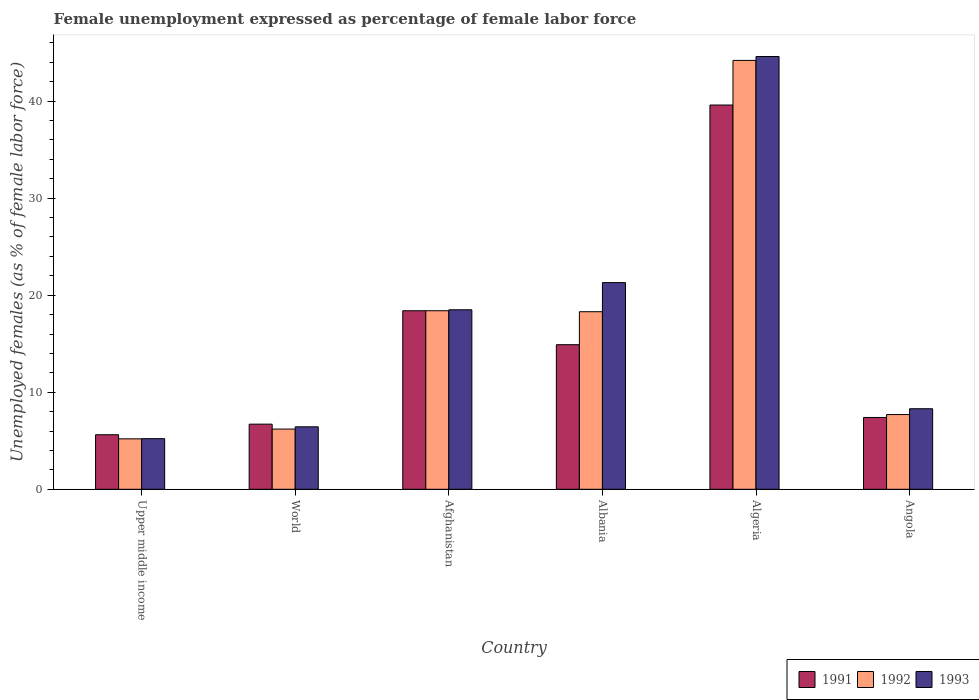Are the number of bars on each tick of the X-axis equal?
Provide a short and direct response. Yes. How many bars are there on the 2nd tick from the left?
Your response must be concise. 3. What is the label of the 4th group of bars from the left?
Your response must be concise. Albania. What is the unemployment in females in in 1991 in World?
Make the answer very short. 6.71. Across all countries, what is the maximum unemployment in females in in 1993?
Keep it short and to the point. 44.6. Across all countries, what is the minimum unemployment in females in in 1991?
Offer a terse response. 5.62. In which country was the unemployment in females in in 1992 maximum?
Give a very brief answer. Algeria. In which country was the unemployment in females in in 1991 minimum?
Your answer should be very brief. Upper middle income. What is the total unemployment in females in in 1992 in the graph?
Offer a terse response. 100. What is the difference between the unemployment in females in in 1991 in Algeria and that in Angola?
Keep it short and to the point. 32.2. What is the difference between the unemployment in females in in 1991 in Albania and the unemployment in females in in 1992 in Angola?
Ensure brevity in your answer.  7.2. What is the average unemployment in females in in 1991 per country?
Your response must be concise. 15.44. What is the difference between the unemployment in females in of/in 1991 and unemployment in females in of/in 1992 in World?
Offer a terse response. 0.51. In how many countries, is the unemployment in females in in 1992 greater than 8 %?
Your answer should be very brief. 3. What is the ratio of the unemployment in females in in 1993 in Albania to that in Upper middle income?
Your response must be concise. 4.08. What is the difference between the highest and the second highest unemployment in females in in 1991?
Your answer should be compact. 3.5. What is the difference between the highest and the lowest unemployment in females in in 1993?
Make the answer very short. 39.38. In how many countries, is the unemployment in females in in 1991 greater than the average unemployment in females in in 1991 taken over all countries?
Your answer should be compact. 2. What does the 1st bar from the left in World represents?
Ensure brevity in your answer.  1991. How many bars are there?
Your answer should be compact. 18. Are all the bars in the graph horizontal?
Your answer should be compact. No. What is the difference between two consecutive major ticks on the Y-axis?
Offer a terse response. 10. Are the values on the major ticks of Y-axis written in scientific E-notation?
Offer a very short reply. No. Does the graph contain any zero values?
Provide a short and direct response. No. Does the graph contain grids?
Give a very brief answer. No. Where does the legend appear in the graph?
Provide a short and direct response. Bottom right. What is the title of the graph?
Your answer should be very brief. Female unemployment expressed as percentage of female labor force. What is the label or title of the Y-axis?
Offer a terse response. Unemployed females (as % of female labor force). What is the Unemployed females (as % of female labor force) in 1991 in Upper middle income?
Your answer should be very brief. 5.62. What is the Unemployed females (as % of female labor force) in 1992 in Upper middle income?
Make the answer very short. 5.2. What is the Unemployed females (as % of female labor force) of 1993 in Upper middle income?
Ensure brevity in your answer.  5.22. What is the Unemployed females (as % of female labor force) of 1991 in World?
Keep it short and to the point. 6.71. What is the Unemployed females (as % of female labor force) in 1992 in World?
Offer a terse response. 6.2. What is the Unemployed females (as % of female labor force) in 1993 in World?
Ensure brevity in your answer.  6.44. What is the Unemployed females (as % of female labor force) of 1991 in Afghanistan?
Offer a terse response. 18.4. What is the Unemployed females (as % of female labor force) in 1992 in Afghanistan?
Give a very brief answer. 18.4. What is the Unemployed females (as % of female labor force) of 1991 in Albania?
Your answer should be very brief. 14.9. What is the Unemployed females (as % of female labor force) of 1992 in Albania?
Give a very brief answer. 18.3. What is the Unemployed females (as % of female labor force) of 1993 in Albania?
Provide a succinct answer. 21.3. What is the Unemployed females (as % of female labor force) in 1991 in Algeria?
Provide a succinct answer. 39.6. What is the Unemployed females (as % of female labor force) in 1992 in Algeria?
Your response must be concise. 44.2. What is the Unemployed females (as % of female labor force) of 1993 in Algeria?
Provide a short and direct response. 44.6. What is the Unemployed females (as % of female labor force) in 1991 in Angola?
Your response must be concise. 7.4. What is the Unemployed females (as % of female labor force) in 1992 in Angola?
Offer a very short reply. 7.7. What is the Unemployed females (as % of female labor force) of 1993 in Angola?
Ensure brevity in your answer.  8.3. Across all countries, what is the maximum Unemployed females (as % of female labor force) in 1991?
Give a very brief answer. 39.6. Across all countries, what is the maximum Unemployed females (as % of female labor force) of 1992?
Your response must be concise. 44.2. Across all countries, what is the maximum Unemployed females (as % of female labor force) of 1993?
Provide a short and direct response. 44.6. Across all countries, what is the minimum Unemployed females (as % of female labor force) in 1991?
Your response must be concise. 5.62. Across all countries, what is the minimum Unemployed females (as % of female labor force) of 1992?
Your response must be concise. 5.2. Across all countries, what is the minimum Unemployed females (as % of female labor force) of 1993?
Your answer should be compact. 5.22. What is the total Unemployed females (as % of female labor force) in 1991 in the graph?
Make the answer very short. 92.63. What is the total Unemployed females (as % of female labor force) in 1992 in the graph?
Make the answer very short. 100. What is the total Unemployed females (as % of female labor force) of 1993 in the graph?
Give a very brief answer. 104.36. What is the difference between the Unemployed females (as % of female labor force) of 1991 in Upper middle income and that in World?
Give a very brief answer. -1.09. What is the difference between the Unemployed females (as % of female labor force) in 1992 in Upper middle income and that in World?
Provide a short and direct response. -1.01. What is the difference between the Unemployed females (as % of female labor force) in 1993 in Upper middle income and that in World?
Ensure brevity in your answer.  -1.22. What is the difference between the Unemployed females (as % of female labor force) in 1991 in Upper middle income and that in Afghanistan?
Make the answer very short. -12.78. What is the difference between the Unemployed females (as % of female labor force) of 1992 in Upper middle income and that in Afghanistan?
Ensure brevity in your answer.  -13.2. What is the difference between the Unemployed females (as % of female labor force) of 1993 in Upper middle income and that in Afghanistan?
Your answer should be compact. -13.28. What is the difference between the Unemployed females (as % of female labor force) of 1991 in Upper middle income and that in Albania?
Offer a very short reply. -9.28. What is the difference between the Unemployed females (as % of female labor force) in 1992 in Upper middle income and that in Albania?
Offer a very short reply. -13.1. What is the difference between the Unemployed females (as % of female labor force) of 1993 in Upper middle income and that in Albania?
Offer a terse response. -16.08. What is the difference between the Unemployed females (as % of female labor force) of 1991 in Upper middle income and that in Algeria?
Your response must be concise. -33.98. What is the difference between the Unemployed females (as % of female labor force) of 1992 in Upper middle income and that in Algeria?
Give a very brief answer. -39. What is the difference between the Unemployed females (as % of female labor force) in 1993 in Upper middle income and that in Algeria?
Offer a very short reply. -39.38. What is the difference between the Unemployed females (as % of female labor force) in 1991 in Upper middle income and that in Angola?
Offer a very short reply. -1.78. What is the difference between the Unemployed females (as % of female labor force) in 1992 in Upper middle income and that in Angola?
Your response must be concise. -2.5. What is the difference between the Unemployed females (as % of female labor force) of 1993 in Upper middle income and that in Angola?
Give a very brief answer. -3.08. What is the difference between the Unemployed females (as % of female labor force) in 1991 in World and that in Afghanistan?
Your answer should be compact. -11.69. What is the difference between the Unemployed females (as % of female labor force) in 1992 in World and that in Afghanistan?
Provide a short and direct response. -12.2. What is the difference between the Unemployed females (as % of female labor force) of 1993 in World and that in Afghanistan?
Provide a short and direct response. -12.06. What is the difference between the Unemployed females (as % of female labor force) of 1991 in World and that in Albania?
Offer a terse response. -8.19. What is the difference between the Unemployed females (as % of female labor force) of 1992 in World and that in Albania?
Offer a terse response. -12.1. What is the difference between the Unemployed females (as % of female labor force) in 1993 in World and that in Albania?
Your answer should be compact. -14.86. What is the difference between the Unemployed females (as % of female labor force) of 1991 in World and that in Algeria?
Your answer should be compact. -32.89. What is the difference between the Unemployed females (as % of female labor force) in 1992 in World and that in Algeria?
Your response must be concise. -38. What is the difference between the Unemployed females (as % of female labor force) in 1993 in World and that in Algeria?
Give a very brief answer. -38.16. What is the difference between the Unemployed females (as % of female labor force) of 1991 in World and that in Angola?
Keep it short and to the point. -0.69. What is the difference between the Unemployed females (as % of female labor force) in 1992 in World and that in Angola?
Your answer should be very brief. -1.5. What is the difference between the Unemployed females (as % of female labor force) of 1993 in World and that in Angola?
Provide a short and direct response. -1.86. What is the difference between the Unemployed females (as % of female labor force) of 1992 in Afghanistan and that in Albania?
Your answer should be compact. 0.1. What is the difference between the Unemployed females (as % of female labor force) in 1991 in Afghanistan and that in Algeria?
Offer a very short reply. -21.2. What is the difference between the Unemployed females (as % of female labor force) of 1992 in Afghanistan and that in Algeria?
Give a very brief answer. -25.8. What is the difference between the Unemployed females (as % of female labor force) of 1993 in Afghanistan and that in Algeria?
Make the answer very short. -26.1. What is the difference between the Unemployed females (as % of female labor force) of 1993 in Afghanistan and that in Angola?
Offer a very short reply. 10.2. What is the difference between the Unemployed females (as % of female labor force) of 1991 in Albania and that in Algeria?
Offer a terse response. -24.7. What is the difference between the Unemployed females (as % of female labor force) of 1992 in Albania and that in Algeria?
Your answer should be compact. -25.9. What is the difference between the Unemployed females (as % of female labor force) in 1993 in Albania and that in Algeria?
Your answer should be compact. -23.3. What is the difference between the Unemployed females (as % of female labor force) of 1991 in Albania and that in Angola?
Your answer should be very brief. 7.5. What is the difference between the Unemployed females (as % of female labor force) in 1991 in Algeria and that in Angola?
Provide a succinct answer. 32.2. What is the difference between the Unemployed females (as % of female labor force) of 1992 in Algeria and that in Angola?
Keep it short and to the point. 36.5. What is the difference between the Unemployed females (as % of female labor force) in 1993 in Algeria and that in Angola?
Your answer should be very brief. 36.3. What is the difference between the Unemployed females (as % of female labor force) of 1991 in Upper middle income and the Unemployed females (as % of female labor force) of 1992 in World?
Keep it short and to the point. -0.58. What is the difference between the Unemployed females (as % of female labor force) of 1991 in Upper middle income and the Unemployed females (as % of female labor force) of 1993 in World?
Provide a short and direct response. -0.82. What is the difference between the Unemployed females (as % of female labor force) in 1992 in Upper middle income and the Unemployed females (as % of female labor force) in 1993 in World?
Ensure brevity in your answer.  -1.24. What is the difference between the Unemployed females (as % of female labor force) of 1991 in Upper middle income and the Unemployed females (as % of female labor force) of 1992 in Afghanistan?
Provide a succinct answer. -12.78. What is the difference between the Unemployed females (as % of female labor force) in 1991 in Upper middle income and the Unemployed females (as % of female labor force) in 1993 in Afghanistan?
Your answer should be compact. -12.88. What is the difference between the Unemployed females (as % of female labor force) of 1992 in Upper middle income and the Unemployed females (as % of female labor force) of 1993 in Afghanistan?
Keep it short and to the point. -13.3. What is the difference between the Unemployed females (as % of female labor force) of 1991 in Upper middle income and the Unemployed females (as % of female labor force) of 1992 in Albania?
Make the answer very short. -12.68. What is the difference between the Unemployed females (as % of female labor force) of 1991 in Upper middle income and the Unemployed females (as % of female labor force) of 1993 in Albania?
Offer a very short reply. -15.68. What is the difference between the Unemployed females (as % of female labor force) of 1992 in Upper middle income and the Unemployed females (as % of female labor force) of 1993 in Albania?
Your answer should be compact. -16.1. What is the difference between the Unemployed females (as % of female labor force) in 1991 in Upper middle income and the Unemployed females (as % of female labor force) in 1992 in Algeria?
Make the answer very short. -38.58. What is the difference between the Unemployed females (as % of female labor force) in 1991 in Upper middle income and the Unemployed females (as % of female labor force) in 1993 in Algeria?
Give a very brief answer. -38.98. What is the difference between the Unemployed females (as % of female labor force) of 1992 in Upper middle income and the Unemployed females (as % of female labor force) of 1993 in Algeria?
Offer a terse response. -39.4. What is the difference between the Unemployed females (as % of female labor force) of 1991 in Upper middle income and the Unemployed females (as % of female labor force) of 1992 in Angola?
Provide a short and direct response. -2.08. What is the difference between the Unemployed females (as % of female labor force) of 1991 in Upper middle income and the Unemployed females (as % of female labor force) of 1993 in Angola?
Give a very brief answer. -2.68. What is the difference between the Unemployed females (as % of female labor force) of 1992 in Upper middle income and the Unemployed females (as % of female labor force) of 1993 in Angola?
Ensure brevity in your answer.  -3.1. What is the difference between the Unemployed females (as % of female labor force) in 1991 in World and the Unemployed females (as % of female labor force) in 1992 in Afghanistan?
Offer a very short reply. -11.69. What is the difference between the Unemployed females (as % of female labor force) in 1991 in World and the Unemployed females (as % of female labor force) in 1993 in Afghanistan?
Make the answer very short. -11.79. What is the difference between the Unemployed females (as % of female labor force) in 1992 in World and the Unemployed females (as % of female labor force) in 1993 in Afghanistan?
Your answer should be compact. -12.3. What is the difference between the Unemployed females (as % of female labor force) in 1991 in World and the Unemployed females (as % of female labor force) in 1992 in Albania?
Provide a succinct answer. -11.59. What is the difference between the Unemployed females (as % of female labor force) in 1991 in World and the Unemployed females (as % of female labor force) in 1993 in Albania?
Ensure brevity in your answer.  -14.59. What is the difference between the Unemployed females (as % of female labor force) of 1992 in World and the Unemployed females (as % of female labor force) of 1993 in Albania?
Provide a short and direct response. -15.1. What is the difference between the Unemployed females (as % of female labor force) of 1991 in World and the Unemployed females (as % of female labor force) of 1992 in Algeria?
Your answer should be compact. -37.49. What is the difference between the Unemployed females (as % of female labor force) in 1991 in World and the Unemployed females (as % of female labor force) in 1993 in Algeria?
Make the answer very short. -37.89. What is the difference between the Unemployed females (as % of female labor force) in 1992 in World and the Unemployed females (as % of female labor force) in 1993 in Algeria?
Give a very brief answer. -38.4. What is the difference between the Unemployed females (as % of female labor force) of 1991 in World and the Unemployed females (as % of female labor force) of 1992 in Angola?
Your response must be concise. -0.99. What is the difference between the Unemployed females (as % of female labor force) of 1991 in World and the Unemployed females (as % of female labor force) of 1993 in Angola?
Provide a short and direct response. -1.59. What is the difference between the Unemployed females (as % of female labor force) of 1992 in World and the Unemployed females (as % of female labor force) of 1993 in Angola?
Give a very brief answer. -2.1. What is the difference between the Unemployed females (as % of female labor force) of 1991 in Afghanistan and the Unemployed females (as % of female labor force) of 1993 in Albania?
Offer a very short reply. -2.9. What is the difference between the Unemployed females (as % of female labor force) of 1992 in Afghanistan and the Unemployed females (as % of female labor force) of 1993 in Albania?
Your answer should be compact. -2.9. What is the difference between the Unemployed females (as % of female labor force) in 1991 in Afghanistan and the Unemployed females (as % of female labor force) in 1992 in Algeria?
Offer a very short reply. -25.8. What is the difference between the Unemployed females (as % of female labor force) in 1991 in Afghanistan and the Unemployed females (as % of female labor force) in 1993 in Algeria?
Give a very brief answer. -26.2. What is the difference between the Unemployed females (as % of female labor force) of 1992 in Afghanistan and the Unemployed females (as % of female labor force) of 1993 in Algeria?
Offer a very short reply. -26.2. What is the difference between the Unemployed females (as % of female labor force) in 1991 in Afghanistan and the Unemployed females (as % of female labor force) in 1992 in Angola?
Your response must be concise. 10.7. What is the difference between the Unemployed females (as % of female labor force) in 1991 in Afghanistan and the Unemployed females (as % of female labor force) in 1993 in Angola?
Ensure brevity in your answer.  10.1. What is the difference between the Unemployed females (as % of female labor force) of 1991 in Albania and the Unemployed females (as % of female labor force) of 1992 in Algeria?
Keep it short and to the point. -29.3. What is the difference between the Unemployed females (as % of female labor force) in 1991 in Albania and the Unemployed females (as % of female labor force) in 1993 in Algeria?
Provide a short and direct response. -29.7. What is the difference between the Unemployed females (as % of female labor force) of 1992 in Albania and the Unemployed females (as % of female labor force) of 1993 in Algeria?
Provide a short and direct response. -26.3. What is the difference between the Unemployed females (as % of female labor force) of 1991 in Albania and the Unemployed females (as % of female labor force) of 1992 in Angola?
Your answer should be very brief. 7.2. What is the difference between the Unemployed females (as % of female labor force) in 1991 in Albania and the Unemployed females (as % of female labor force) in 1993 in Angola?
Your response must be concise. 6.6. What is the difference between the Unemployed females (as % of female labor force) of 1992 in Albania and the Unemployed females (as % of female labor force) of 1993 in Angola?
Your answer should be very brief. 10. What is the difference between the Unemployed females (as % of female labor force) of 1991 in Algeria and the Unemployed females (as % of female labor force) of 1992 in Angola?
Your response must be concise. 31.9. What is the difference between the Unemployed females (as % of female labor force) in 1991 in Algeria and the Unemployed females (as % of female labor force) in 1993 in Angola?
Keep it short and to the point. 31.3. What is the difference between the Unemployed females (as % of female labor force) in 1992 in Algeria and the Unemployed females (as % of female labor force) in 1993 in Angola?
Ensure brevity in your answer.  35.9. What is the average Unemployed females (as % of female labor force) in 1991 per country?
Make the answer very short. 15.44. What is the average Unemployed females (as % of female labor force) in 1992 per country?
Offer a very short reply. 16.67. What is the average Unemployed females (as % of female labor force) of 1993 per country?
Provide a short and direct response. 17.39. What is the difference between the Unemployed females (as % of female labor force) in 1991 and Unemployed females (as % of female labor force) in 1992 in Upper middle income?
Provide a succinct answer. 0.42. What is the difference between the Unemployed females (as % of female labor force) in 1991 and Unemployed females (as % of female labor force) in 1993 in Upper middle income?
Make the answer very short. 0.4. What is the difference between the Unemployed females (as % of female labor force) of 1992 and Unemployed females (as % of female labor force) of 1993 in Upper middle income?
Keep it short and to the point. -0.02. What is the difference between the Unemployed females (as % of female labor force) in 1991 and Unemployed females (as % of female labor force) in 1992 in World?
Your answer should be compact. 0.51. What is the difference between the Unemployed females (as % of female labor force) of 1991 and Unemployed females (as % of female labor force) of 1993 in World?
Ensure brevity in your answer.  0.27. What is the difference between the Unemployed females (as % of female labor force) in 1992 and Unemployed females (as % of female labor force) in 1993 in World?
Give a very brief answer. -0.23. What is the difference between the Unemployed females (as % of female labor force) in 1991 and Unemployed females (as % of female labor force) in 1992 in Afghanistan?
Offer a very short reply. 0. What is the difference between the Unemployed females (as % of female labor force) in 1992 and Unemployed females (as % of female labor force) in 1993 in Afghanistan?
Offer a terse response. -0.1. What is the difference between the Unemployed females (as % of female labor force) of 1991 and Unemployed females (as % of female labor force) of 1992 in Albania?
Offer a terse response. -3.4. What is the difference between the Unemployed females (as % of female labor force) of 1992 and Unemployed females (as % of female labor force) of 1993 in Albania?
Provide a short and direct response. -3. What is the difference between the Unemployed females (as % of female labor force) in 1992 and Unemployed females (as % of female labor force) in 1993 in Angola?
Ensure brevity in your answer.  -0.6. What is the ratio of the Unemployed females (as % of female labor force) of 1991 in Upper middle income to that in World?
Your response must be concise. 0.84. What is the ratio of the Unemployed females (as % of female labor force) of 1992 in Upper middle income to that in World?
Your answer should be very brief. 0.84. What is the ratio of the Unemployed females (as % of female labor force) of 1993 in Upper middle income to that in World?
Offer a terse response. 0.81. What is the ratio of the Unemployed females (as % of female labor force) in 1991 in Upper middle income to that in Afghanistan?
Offer a terse response. 0.31. What is the ratio of the Unemployed females (as % of female labor force) of 1992 in Upper middle income to that in Afghanistan?
Offer a terse response. 0.28. What is the ratio of the Unemployed females (as % of female labor force) in 1993 in Upper middle income to that in Afghanistan?
Your answer should be compact. 0.28. What is the ratio of the Unemployed females (as % of female labor force) in 1991 in Upper middle income to that in Albania?
Keep it short and to the point. 0.38. What is the ratio of the Unemployed females (as % of female labor force) of 1992 in Upper middle income to that in Albania?
Keep it short and to the point. 0.28. What is the ratio of the Unemployed females (as % of female labor force) of 1993 in Upper middle income to that in Albania?
Give a very brief answer. 0.24. What is the ratio of the Unemployed females (as % of female labor force) in 1991 in Upper middle income to that in Algeria?
Offer a terse response. 0.14. What is the ratio of the Unemployed females (as % of female labor force) of 1992 in Upper middle income to that in Algeria?
Your answer should be compact. 0.12. What is the ratio of the Unemployed females (as % of female labor force) of 1993 in Upper middle income to that in Algeria?
Provide a succinct answer. 0.12. What is the ratio of the Unemployed females (as % of female labor force) in 1991 in Upper middle income to that in Angola?
Offer a very short reply. 0.76. What is the ratio of the Unemployed females (as % of female labor force) of 1992 in Upper middle income to that in Angola?
Keep it short and to the point. 0.68. What is the ratio of the Unemployed females (as % of female labor force) in 1993 in Upper middle income to that in Angola?
Your answer should be compact. 0.63. What is the ratio of the Unemployed females (as % of female labor force) in 1991 in World to that in Afghanistan?
Provide a short and direct response. 0.36. What is the ratio of the Unemployed females (as % of female labor force) of 1992 in World to that in Afghanistan?
Make the answer very short. 0.34. What is the ratio of the Unemployed females (as % of female labor force) in 1993 in World to that in Afghanistan?
Ensure brevity in your answer.  0.35. What is the ratio of the Unemployed females (as % of female labor force) in 1991 in World to that in Albania?
Your response must be concise. 0.45. What is the ratio of the Unemployed females (as % of female labor force) in 1992 in World to that in Albania?
Offer a terse response. 0.34. What is the ratio of the Unemployed females (as % of female labor force) of 1993 in World to that in Albania?
Offer a very short reply. 0.3. What is the ratio of the Unemployed females (as % of female labor force) of 1991 in World to that in Algeria?
Make the answer very short. 0.17. What is the ratio of the Unemployed females (as % of female labor force) in 1992 in World to that in Algeria?
Offer a terse response. 0.14. What is the ratio of the Unemployed females (as % of female labor force) of 1993 in World to that in Algeria?
Make the answer very short. 0.14. What is the ratio of the Unemployed females (as % of female labor force) in 1991 in World to that in Angola?
Give a very brief answer. 0.91. What is the ratio of the Unemployed females (as % of female labor force) of 1992 in World to that in Angola?
Your answer should be compact. 0.81. What is the ratio of the Unemployed females (as % of female labor force) of 1993 in World to that in Angola?
Ensure brevity in your answer.  0.78. What is the ratio of the Unemployed females (as % of female labor force) of 1991 in Afghanistan to that in Albania?
Ensure brevity in your answer.  1.23. What is the ratio of the Unemployed females (as % of female labor force) in 1992 in Afghanistan to that in Albania?
Provide a short and direct response. 1.01. What is the ratio of the Unemployed females (as % of female labor force) of 1993 in Afghanistan to that in Albania?
Offer a very short reply. 0.87. What is the ratio of the Unemployed females (as % of female labor force) in 1991 in Afghanistan to that in Algeria?
Offer a very short reply. 0.46. What is the ratio of the Unemployed females (as % of female labor force) in 1992 in Afghanistan to that in Algeria?
Your response must be concise. 0.42. What is the ratio of the Unemployed females (as % of female labor force) in 1993 in Afghanistan to that in Algeria?
Your answer should be compact. 0.41. What is the ratio of the Unemployed females (as % of female labor force) of 1991 in Afghanistan to that in Angola?
Your answer should be very brief. 2.49. What is the ratio of the Unemployed females (as % of female labor force) of 1992 in Afghanistan to that in Angola?
Give a very brief answer. 2.39. What is the ratio of the Unemployed females (as % of female labor force) of 1993 in Afghanistan to that in Angola?
Offer a terse response. 2.23. What is the ratio of the Unemployed females (as % of female labor force) of 1991 in Albania to that in Algeria?
Provide a succinct answer. 0.38. What is the ratio of the Unemployed females (as % of female labor force) in 1992 in Albania to that in Algeria?
Offer a terse response. 0.41. What is the ratio of the Unemployed females (as % of female labor force) in 1993 in Albania to that in Algeria?
Give a very brief answer. 0.48. What is the ratio of the Unemployed females (as % of female labor force) of 1991 in Albania to that in Angola?
Provide a succinct answer. 2.01. What is the ratio of the Unemployed females (as % of female labor force) in 1992 in Albania to that in Angola?
Offer a very short reply. 2.38. What is the ratio of the Unemployed females (as % of female labor force) in 1993 in Albania to that in Angola?
Keep it short and to the point. 2.57. What is the ratio of the Unemployed females (as % of female labor force) of 1991 in Algeria to that in Angola?
Your response must be concise. 5.35. What is the ratio of the Unemployed females (as % of female labor force) in 1992 in Algeria to that in Angola?
Provide a succinct answer. 5.74. What is the ratio of the Unemployed females (as % of female labor force) in 1993 in Algeria to that in Angola?
Offer a terse response. 5.37. What is the difference between the highest and the second highest Unemployed females (as % of female labor force) of 1991?
Offer a very short reply. 21.2. What is the difference between the highest and the second highest Unemployed females (as % of female labor force) in 1992?
Offer a terse response. 25.8. What is the difference between the highest and the second highest Unemployed females (as % of female labor force) in 1993?
Give a very brief answer. 23.3. What is the difference between the highest and the lowest Unemployed females (as % of female labor force) in 1991?
Provide a short and direct response. 33.98. What is the difference between the highest and the lowest Unemployed females (as % of female labor force) of 1992?
Offer a terse response. 39. What is the difference between the highest and the lowest Unemployed females (as % of female labor force) in 1993?
Provide a succinct answer. 39.38. 